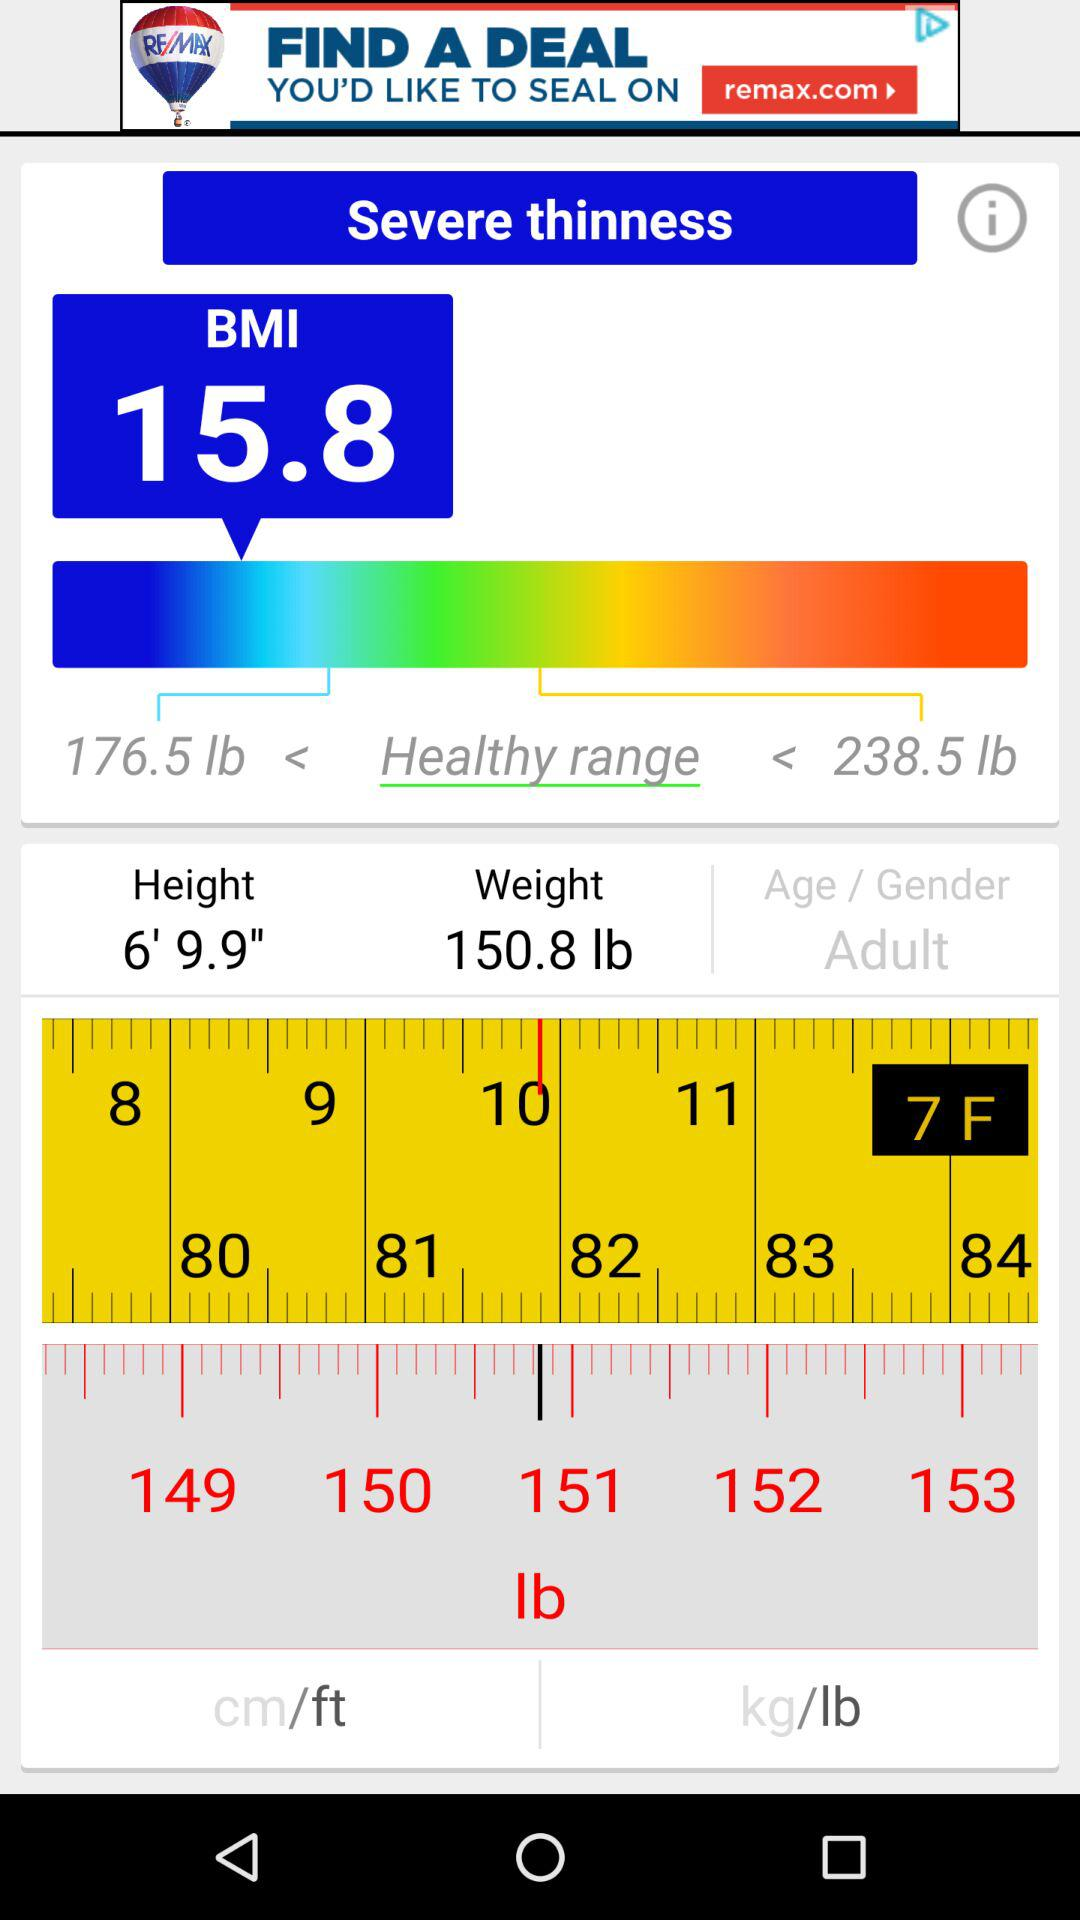How much BMI is given? The given BMI is 15.8. 